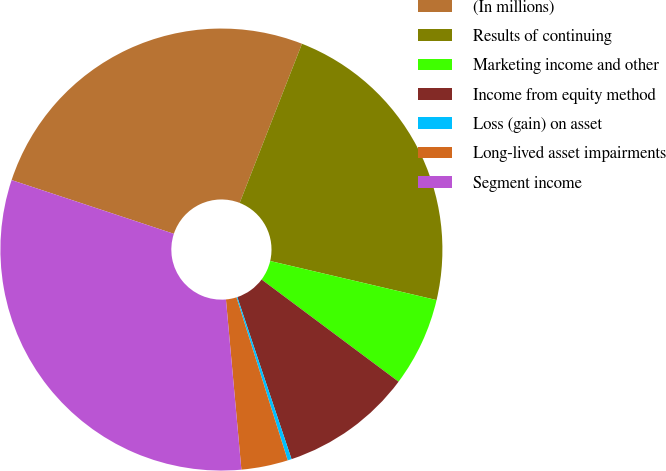Convert chart to OTSL. <chart><loc_0><loc_0><loc_500><loc_500><pie_chart><fcel>(In millions)<fcel>Results of continuing<fcel>Marketing income and other<fcel>Income from equity method<fcel>Loss (gain) on asset<fcel>Long-lived asset impairments<fcel>Segment income<nl><fcel>25.85%<fcel>22.73%<fcel>6.53%<fcel>9.66%<fcel>0.29%<fcel>3.41%<fcel>31.53%<nl></chart> 